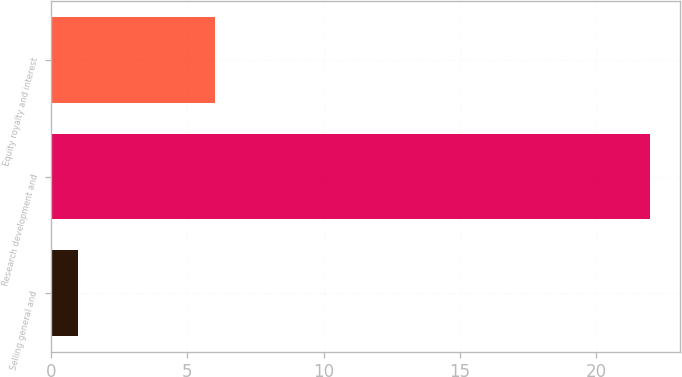Convert chart to OTSL. <chart><loc_0><loc_0><loc_500><loc_500><bar_chart><fcel>Selling general and<fcel>Research development and<fcel>Equity royalty and interest<nl><fcel>1<fcel>22<fcel>6<nl></chart> 